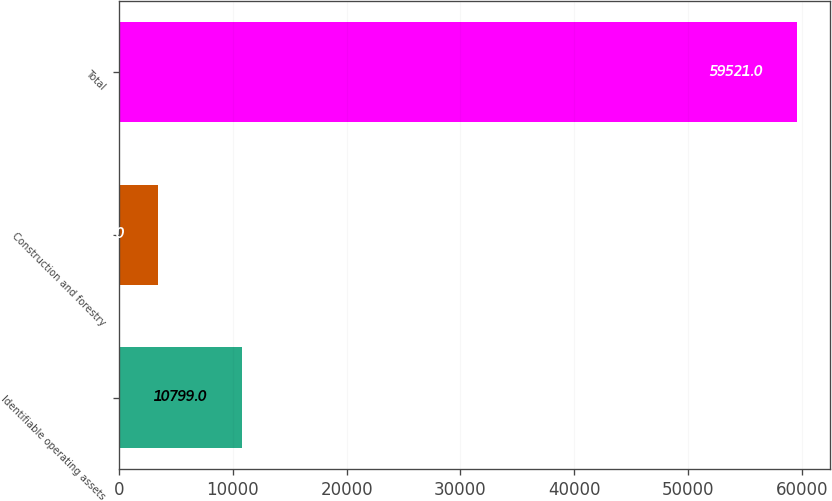Convert chart. <chart><loc_0><loc_0><loc_500><loc_500><bar_chart><fcel>Identifiable operating assets<fcel>Construction and forestry<fcel>Total<nl><fcel>10799<fcel>3461<fcel>59521<nl></chart> 